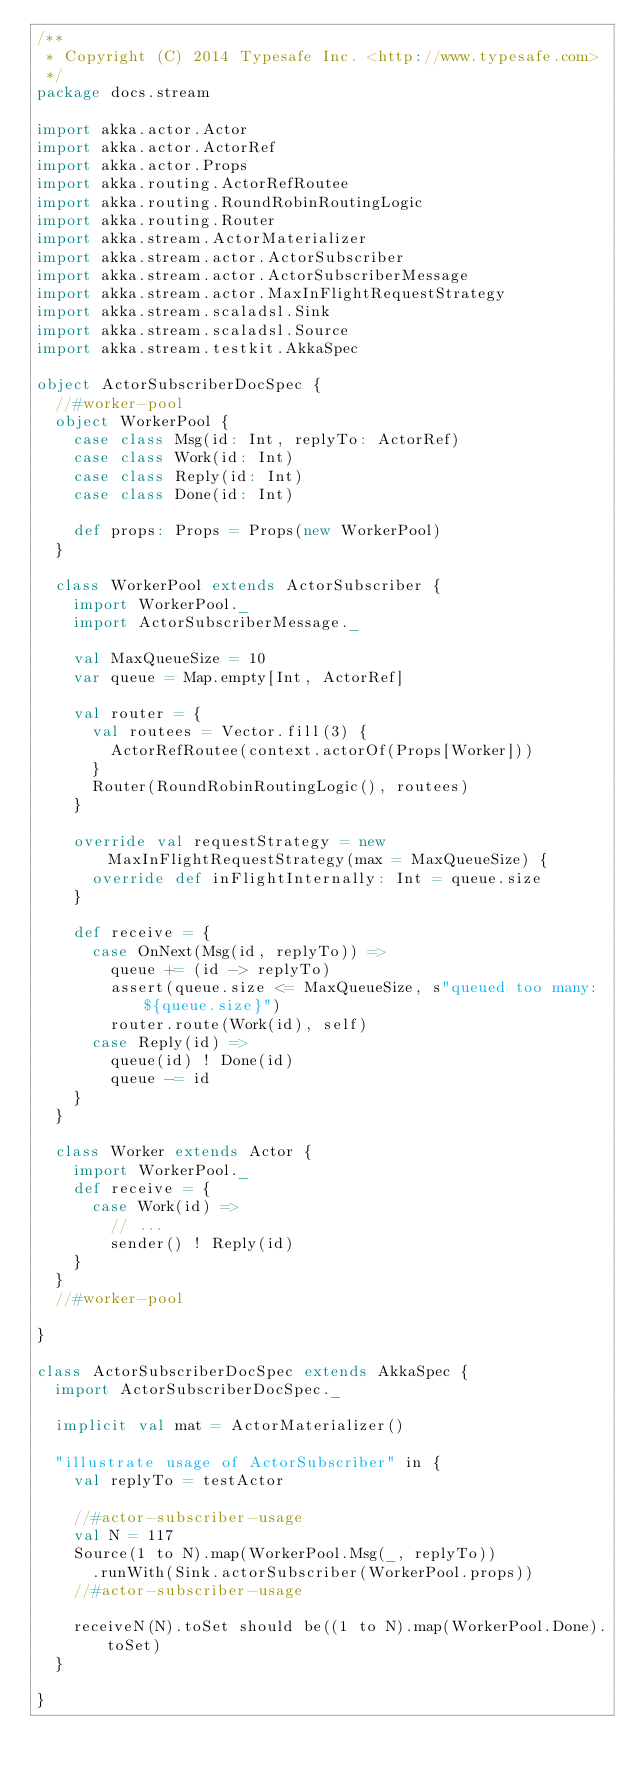<code> <loc_0><loc_0><loc_500><loc_500><_Scala_>/**
 * Copyright (C) 2014 Typesafe Inc. <http://www.typesafe.com>
 */
package docs.stream

import akka.actor.Actor
import akka.actor.ActorRef
import akka.actor.Props
import akka.routing.ActorRefRoutee
import akka.routing.RoundRobinRoutingLogic
import akka.routing.Router
import akka.stream.ActorMaterializer
import akka.stream.actor.ActorSubscriber
import akka.stream.actor.ActorSubscriberMessage
import akka.stream.actor.MaxInFlightRequestStrategy
import akka.stream.scaladsl.Sink
import akka.stream.scaladsl.Source
import akka.stream.testkit.AkkaSpec

object ActorSubscriberDocSpec {
  //#worker-pool
  object WorkerPool {
    case class Msg(id: Int, replyTo: ActorRef)
    case class Work(id: Int)
    case class Reply(id: Int)
    case class Done(id: Int)

    def props: Props = Props(new WorkerPool)
  }

  class WorkerPool extends ActorSubscriber {
    import WorkerPool._
    import ActorSubscriberMessage._

    val MaxQueueSize = 10
    var queue = Map.empty[Int, ActorRef]

    val router = {
      val routees = Vector.fill(3) {
        ActorRefRoutee(context.actorOf(Props[Worker]))
      }
      Router(RoundRobinRoutingLogic(), routees)
    }

    override val requestStrategy = new MaxInFlightRequestStrategy(max = MaxQueueSize) {
      override def inFlightInternally: Int = queue.size
    }

    def receive = {
      case OnNext(Msg(id, replyTo)) =>
        queue += (id -> replyTo)
        assert(queue.size <= MaxQueueSize, s"queued too many: ${queue.size}")
        router.route(Work(id), self)
      case Reply(id) =>
        queue(id) ! Done(id)
        queue -= id
    }
  }

  class Worker extends Actor {
    import WorkerPool._
    def receive = {
      case Work(id) =>
        // ...
        sender() ! Reply(id)
    }
  }
  //#worker-pool

}

class ActorSubscriberDocSpec extends AkkaSpec {
  import ActorSubscriberDocSpec._

  implicit val mat = ActorMaterializer()

  "illustrate usage of ActorSubscriber" in {
    val replyTo = testActor

    //#actor-subscriber-usage
    val N = 117
    Source(1 to N).map(WorkerPool.Msg(_, replyTo))
      .runWith(Sink.actorSubscriber(WorkerPool.props))
    //#actor-subscriber-usage

    receiveN(N).toSet should be((1 to N).map(WorkerPool.Done).toSet)
  }

}
</code> 